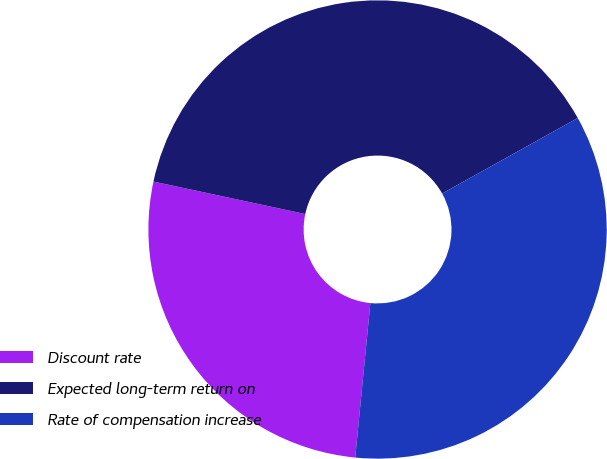Convert chart to OTSL. <chart><loc_0><loc_0><loc_500><loc_500><pie_chart><fcel>Discount rate<fcel>Expected long-term return on<fcel>Rate of compensation increase<nl><fcel>26.8%<fcel>38.56%<fcel>34.64%<nl></chart> 